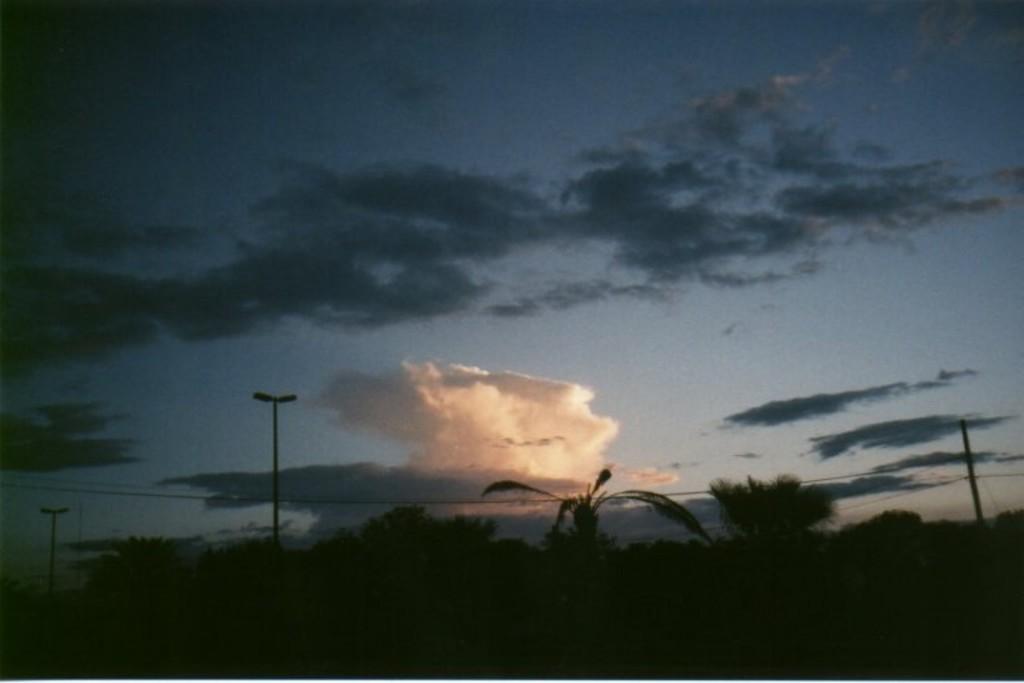Could you give a brief overview of what you see in this image? This image is taken outdoors. At the top of the image there is a sky with clouds. At the bottom of the image there are a few trees and there are three poles with street lights. 